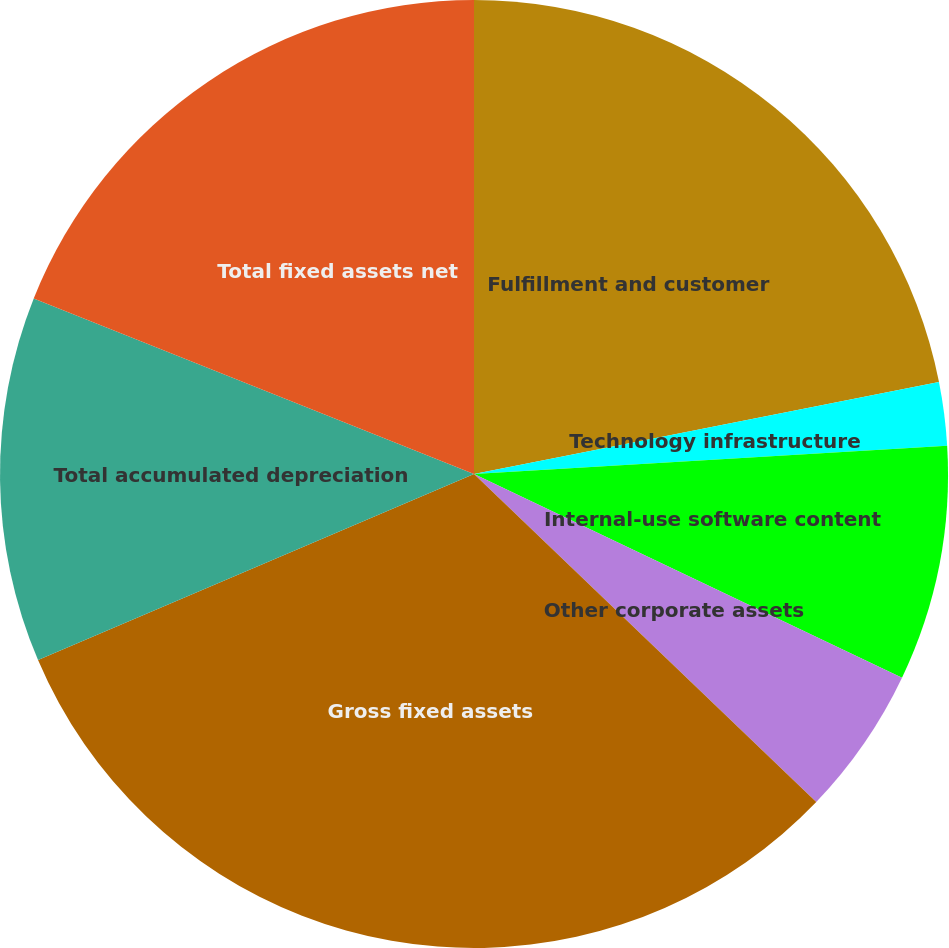<chart> <loc_0><loc_0><loc_500><loc_500><pie_chart><fcel>Fulfillment and customer<fcel>Technology infrastructure<fcel>Internal-use software content<fcel>Other corporate assets<fcel>Gross fixed assets<fcel>Total accumulated depreciation<fcel>Total fixed assets net<nl><fcel>21.89%<fcel>2.16%<fcel>8.02%<fcel>5.09%<fcel>31.42%<fcel>12.46%<fcel>18.96%<nl></chart> 